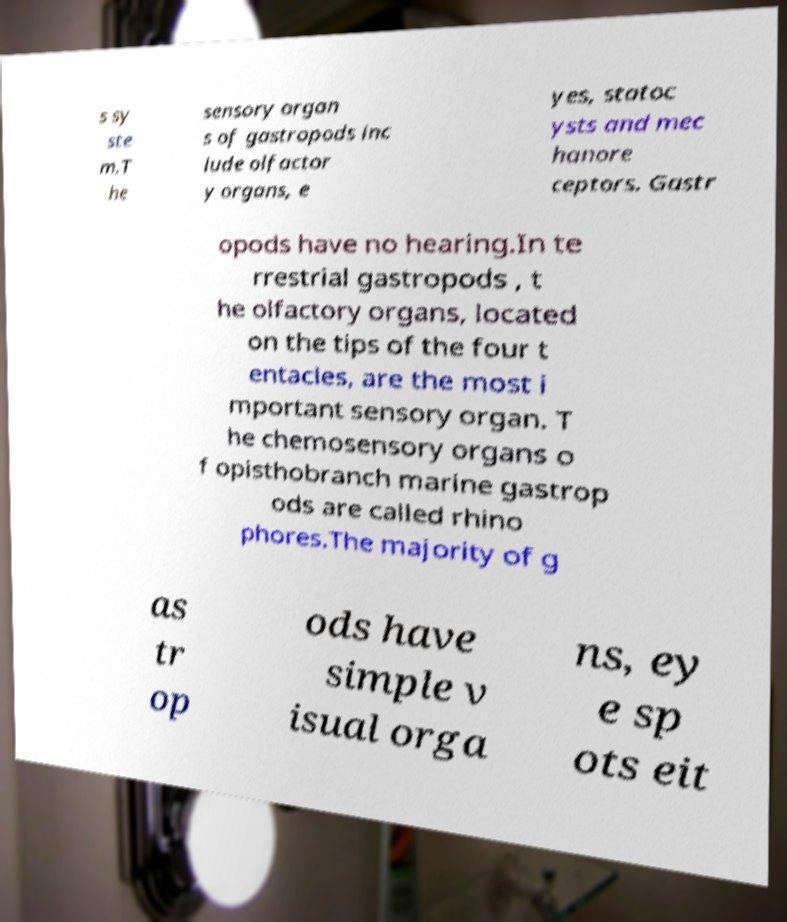For documentation purposes, I need the text within this image transcribed. Could you provide that? s sy ste m.T he sensory organ s of gastropods inc lude olfactor y organs, e yes, statoc ysts and mec hanore ceptors. Gastr opods have no hearing.In te rrestrial gastropods , t he olfactory organs, located on the tips of the four t entacles, are the most i mportant sensory organ. T he chemosensory organs o f opisthobranch marine gastrop ods are called rhino phores.The majority of g as tr op ods have simple v isual orga ns, ey e sp ots eit 